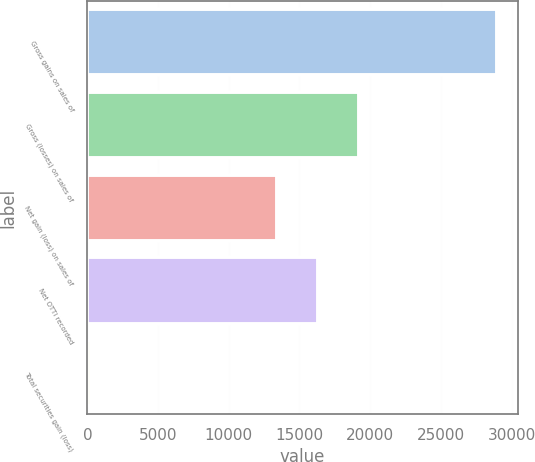Convert chart. <chart><loc_0><loc_0><loc_500><loc_500><bar_chart><fcel>Gross gains on sales of<fcel>Gross (losses) on sales of<fcel>Net gain (loss) on sales of<fcel>Net OTTI recorded<fcel>Total securities gain (loss)<nl><fcel>28992<fcel>19191.6<fcel>13448<fcel>16319.8<fcel>274<nl></chart> 